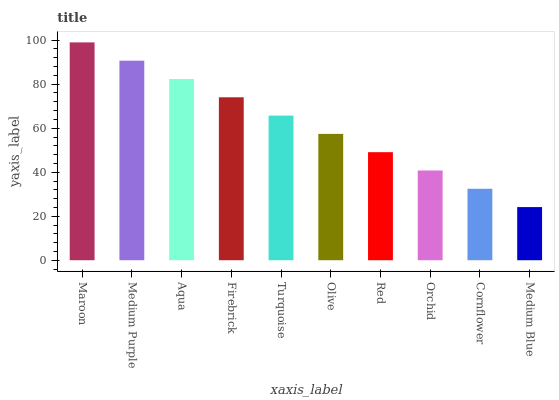Is Medium Blue the minimum?
Answer yes or no. Yes. Is Maroon the maximum?
Answer yes or no. Yes. Is Medium Purple the minimum?
Answer yes or no. No. Is Medium Purple the maximum?
Answer yes or no. No. Is Maroon greater than Medium Purple?
Answer yes or no. Yes. Is Medium Purple less than Maroon?
Answer yes or no. Yes. Is Medium Purple greater than Maroon?
Answer yes or no. No. Is Maroon less than Medium Purple?
Answer yes or no. No. Is Turquoise the high median?
Answer yes or no. Yes. Is Olive the low median?
Answer yes or no. Yes. Is Maroon the high median?
Answer yes or no. No. Is Medium Blue the low median?
Answer yes or no. No. 